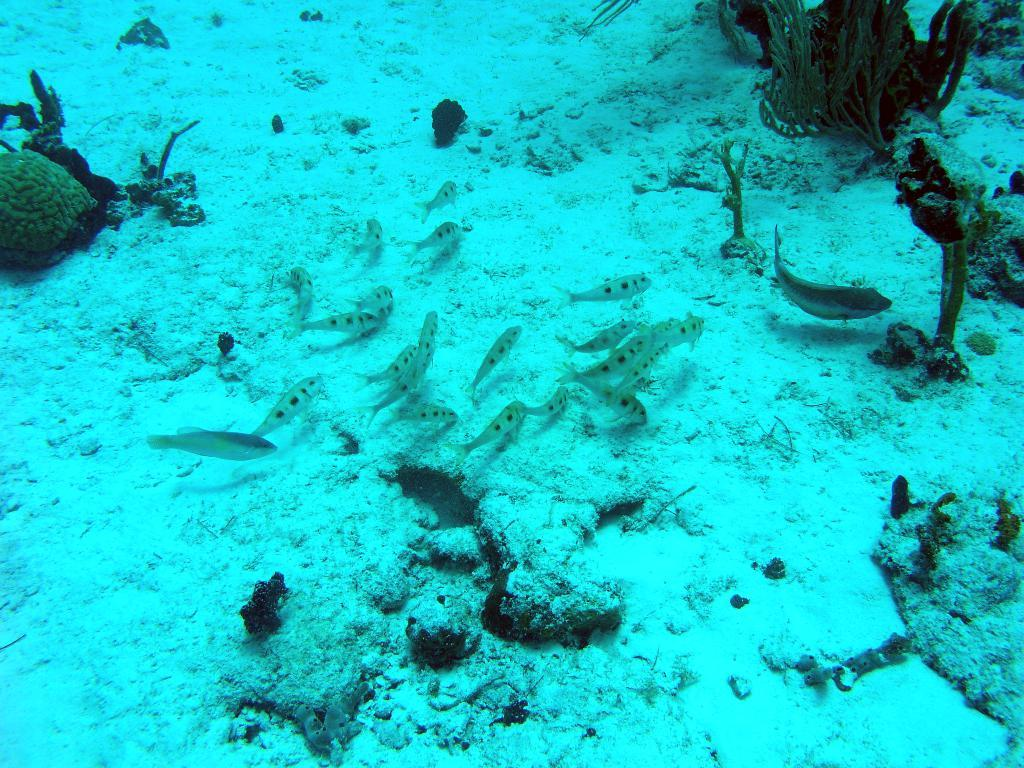What type of environment is shown in the image? The image depicts an underwater scene. What type of marine life can be seen in the image? There are fish present in the image. What can be found on the ground in the underwater scene? There are stones visible on the ground. What type of vegetation is present in the image? Plants are present in the image. What type of food is being prepared by the fish in the image? There is no indication in the image that the fish are preparing food; they are simply swimming in their underwater environment. 